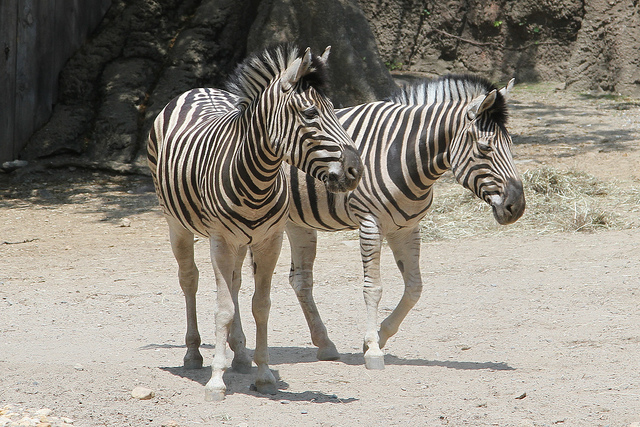<image>Where are the giraffes? There are no giraffes in the image. However, they might be at a zoo or in a field. Where are the giraffes? The giraffes are not present in the image, so it is not possible to determine where they are. 